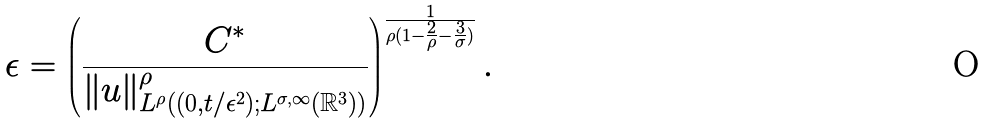Convert formula to latex. <formula><loc_0><loc_0><loc_500><loc_500>\epsilon = \left ( \frac { C ^ { * } } { \| u \| ^ { \rho } _ { L ^ { \rho } ( ( 0 , t / \epsilon ^ { 2 } ) ; L ^ { \sigma , \infty } ( \mathbb { R } ^ { 3 } ) ) } } \right ) ^ { \frac { 1 } { \rho ( 1 - \frac { 2 } { \rho } - \frac { 3 } { \sigma } ) } } .</formula> 